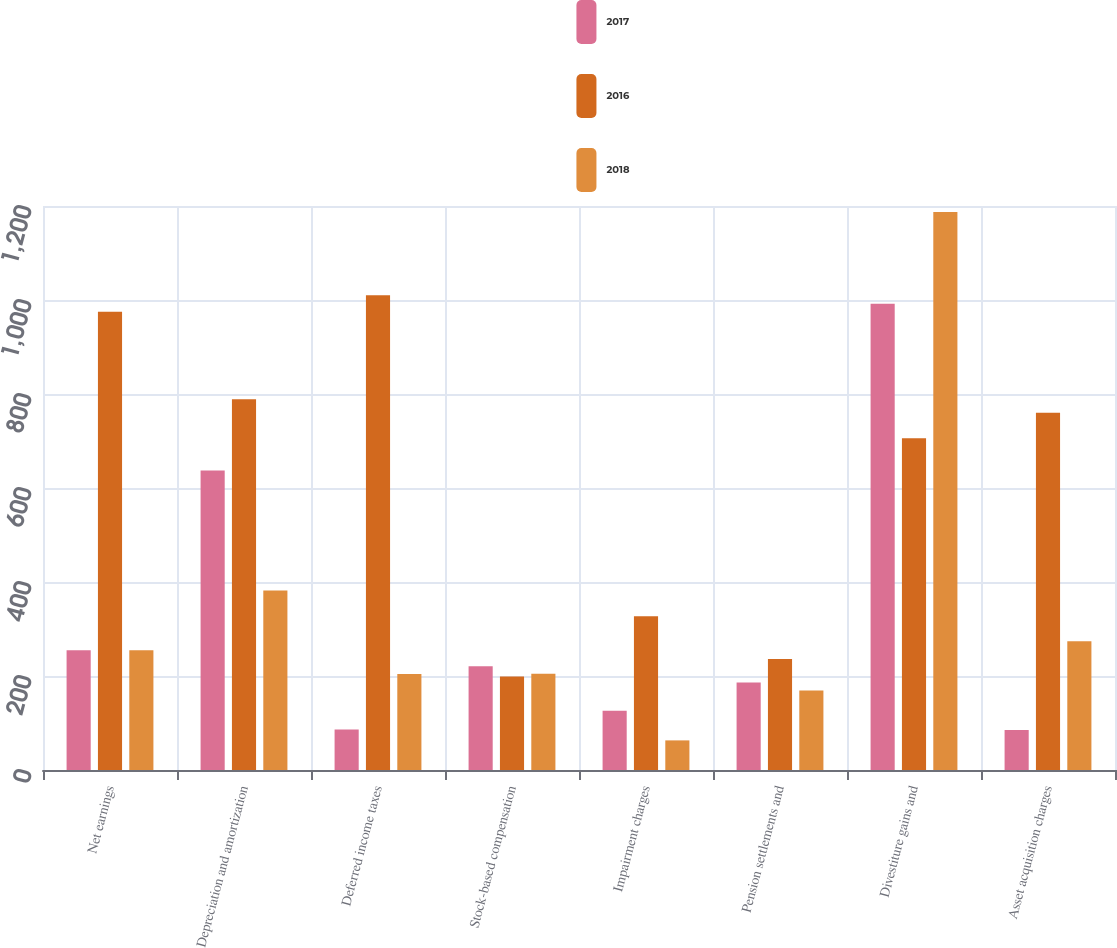<chart> <loc_0><loc_0><loc_500><loc_500><stacked_bar_chart><ecel><fcel>Net earnings<fcel>Depreciation and amortization<fcel>Deferred income taxes<fcel>Stock-based compensation<fcel>Impairment charges<fcel>Pension settlements and<fcel>Divestiture gains and<fcel>Asset acquisition charges<nl><fcel>2017<fcel>255<fcel>637<fcel>86<fcel>221<fcel>126<fcel>186<fcel>992<fcel>85<nl><fcel>2016<fcel>975<fcel>789<fcel>1010<fcel>199<fcel>327<fcel>236<fcel>706<fcel>760<nl><fcel>2018<fcel>255<fcel>382<fcel>204<fcel>205<fcel>63<fcel>169<fcel>1187<fcel>274<nl></chart> 